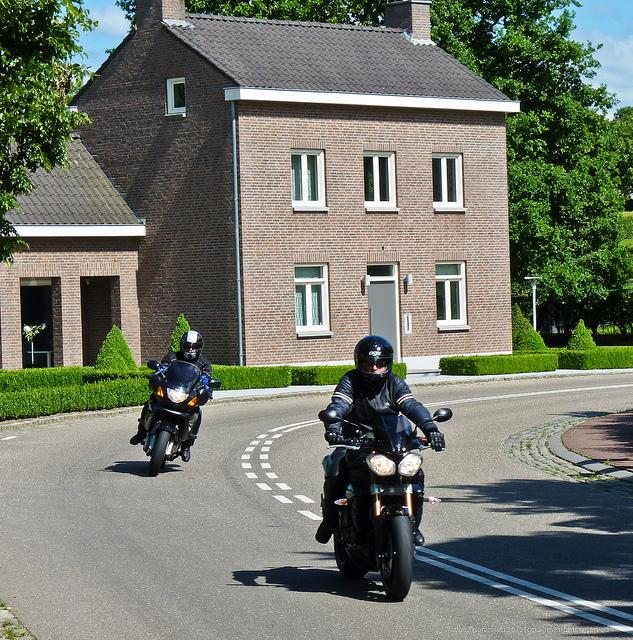What color are the stripes on the sleeves of the jacket worn by the motorcyclist in front? Please explain your reasoning. white. The color of the stripes is grayish white. 